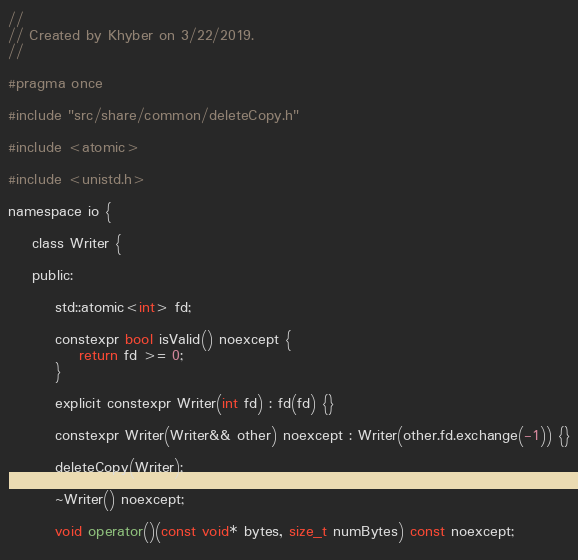Convert code to text. <code><loc_0><loc_0><loc_500><loc_500><_C_>//
// Created by Khyber on 3/22/2019.
//

#pragma once

#include "src/share/common/deleteCopy.h"

#include <atomic>

#include <unistd.h>

namespace io {
    
    class Writer {
    
    public:
        
        std::atomic<int> fd;
        
        constexpr bool isValid() noexcept {
            return fd >= 0;
        }
        
        explicit constexpr Writer(int fd) : fd(fd) {}
        
        constexpr Writer(Writer&& other) noexcept : Writer(other.fd.exchange(-1)) {}
        
        deleteCopy(Writer);
        
        ~Writer() noexcept;
        
        void operator()(const void* bytes, size_t numBytes) const noexcept;
        </code> 